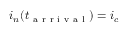Convert formula to latex. <formula><loc_0><loc_0><loc_500><loc_500>i _ { n } ( t _ { a r r i v a l } ) = i _ { c }</formula> 